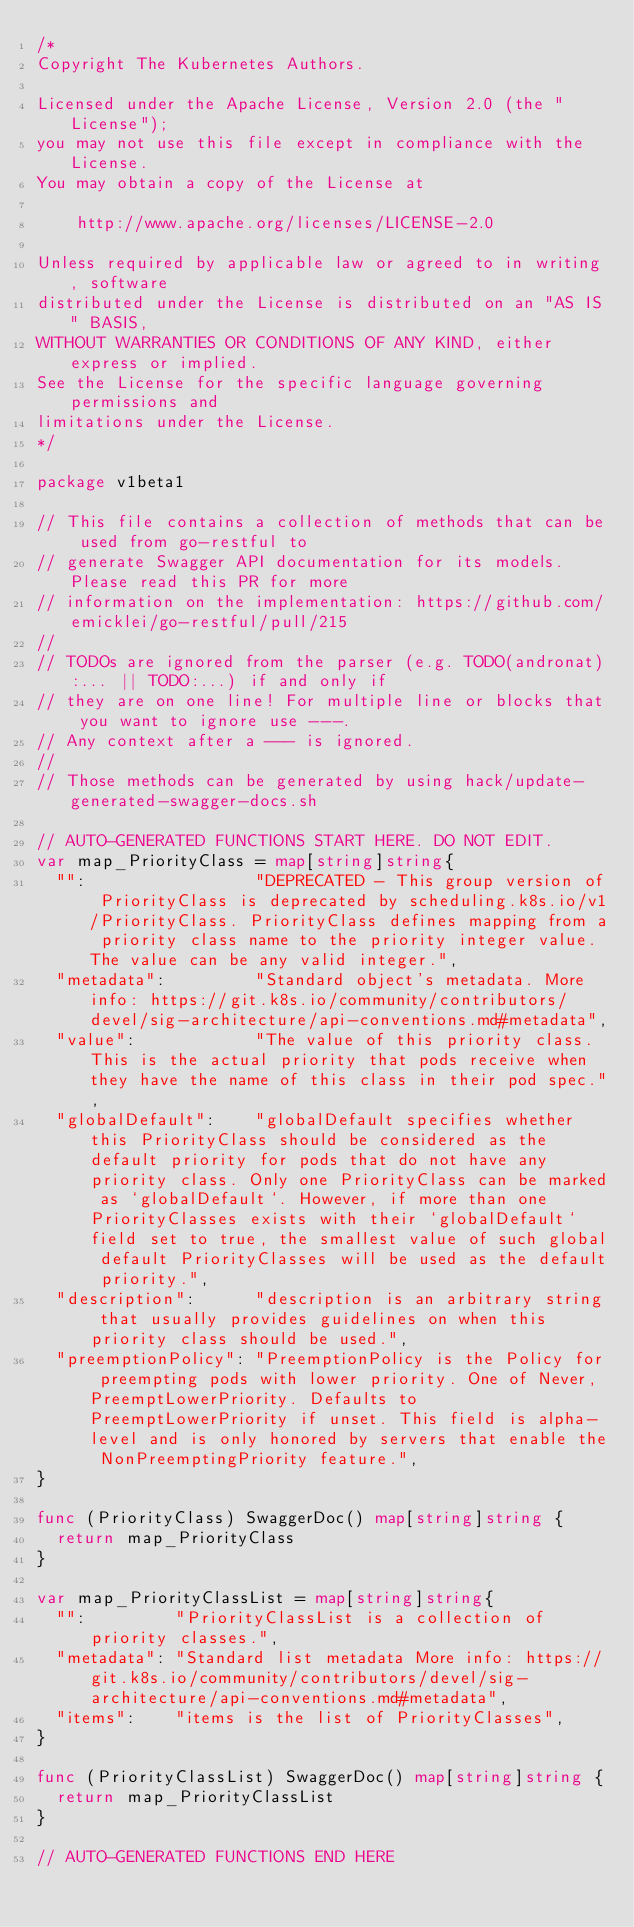<code> <loc_0><loc_0><loc_500><loc_500><_Go_>/*
Copyright The Kubernetes Authors.

Licensed under the Apache License, Version 2.0 (the "License");
you may not use this file except in compliance with the License.
You may obtain a copy of the License at

    http://www.apache.org/licenses/LICENSE-2.0

Unless required by applicable law or agreed to in writing, software
distributed under the License is distributed on an "AS IS" BASIS,
WITHOUT WARRANTIES OR CONDITIONS OF ANY KIND, either express or implied.
See the License for the specific language governing permissions and
limitations under the License.
*/

package v1beta1

// This file contains a collection of methods that can be used from go-restful to
// generate Swagger API documentation for its models. Please read this PR for more
// information on the implementation: https://github.com/emicklei/go-restful/pull/215
//
// TODOs are ignored from the parser (e.g. TODO(andronat):... || TODO:...) if and only if
// they are on one line! For multiple line or blocks that you want to ignore use ---.
// Any context after a --- is ignored.
//
// Those methods can be generated by using hack/update-generated-swagger-docs.sh

// AUTO-GENERATED FUNCTIONS START HERE. DO NOT EDIT.
var map_PriorityClass = map[string]string{
	"":                 "DEPRECATED - This group version of PriorityClass is deprecated by scheduling.k8s.io/v1/PriorityClass. PriorityClass defines mapping from a priority class name to the priority integer value. The value can be any valid integer.",
	"metadata":         "Standard object's metadata. More info: https://git.k8s.io/community/contributors/devel/sig-architecture/api-conventions.md#metadata",
	"value":            "The value of this priority class. This is the actual priority that pods receive when they have the name of this class in their pod spec.",
	"globalDefault":    "globalDefault specifies whether this PriorityClass should be considered as the default priority for pods that do not have any priority class. Only one PriorityClass can be marked as `globalDefault`. However, if more than one PriorityClasses exists with their `globalDefault` field set to true, the smallest value of such global default PriorityClasses will be used as the default priority.",
	"description":      "description is an arbitrary string that usually provides guidelines on when this priority class should be used.",
	"preemptionPolicy": "PreemptionPolicy is the Policy for preempting pods with lower priority. One of Never, PreemptLowerPriority. Defaults to PreemptLowerPriority if unset. This field is alpha-level and is only honored by servers that enable the NonPreemptingPriority feature.",
}

func (PriorityClass) SwaggerDoc() map[string]string {
	return map_PriorityClass
}

var map_PriorityClassList = map[string]string{
	"":         "PriorityClassList is a collection of priority classes.",
	"metadata": "Standard list metadata More info: https://git.k8s.io/community/contributors/devel/sig-architecture/api-conventions.md#metadata",
	"items":    "items is the list of PriorityClasses",
}

func (PriorityClassList) SwaggerDoc() map[string]string {
	return map_PriorityClassList
}

// AUTO-GENERATED FUNCTIONS END HERE
</code> 